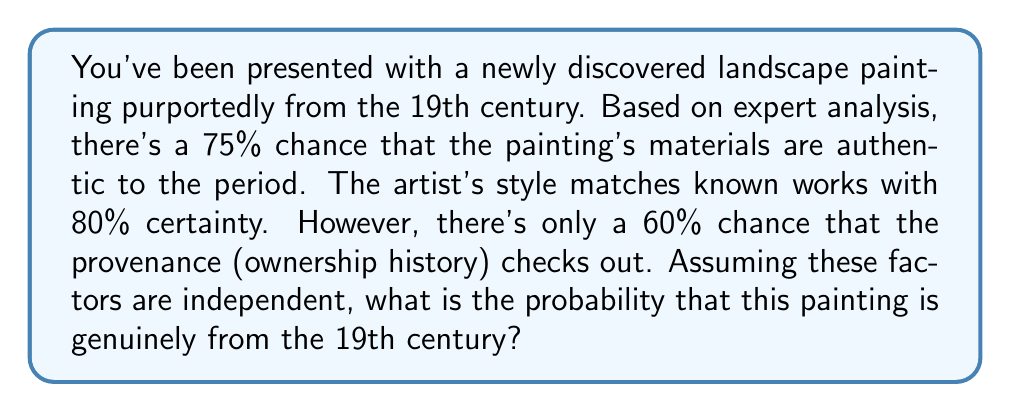Could you help me with this problem? To solve this problem, we need to consider the following steps:

1. Identify the independent events:
   A: Materials are authentic (P(A) = 0.75)
   B: Artist's style matches (P(B) = 0.80)
   C: Provenance checks out (P(C) = 0.60)

2. For the painting to be genuine, all three events must occur simultaneously. Since the events are independent, we can multiply their individual probabilities:

   P(Genuine) = P(A ∩ B ∩ C) = P(A) × P(B) × P(C)

3. Substitute the given probabilities:

   P(Genuine) = 0.75 × 0.80 × 0.60

4. Calculate the result:

   P(Genuine) = 0.36 = 36%

Therefore, the probability that the painting is genuinely from the 19th century is 36%.
Answer: 36% 